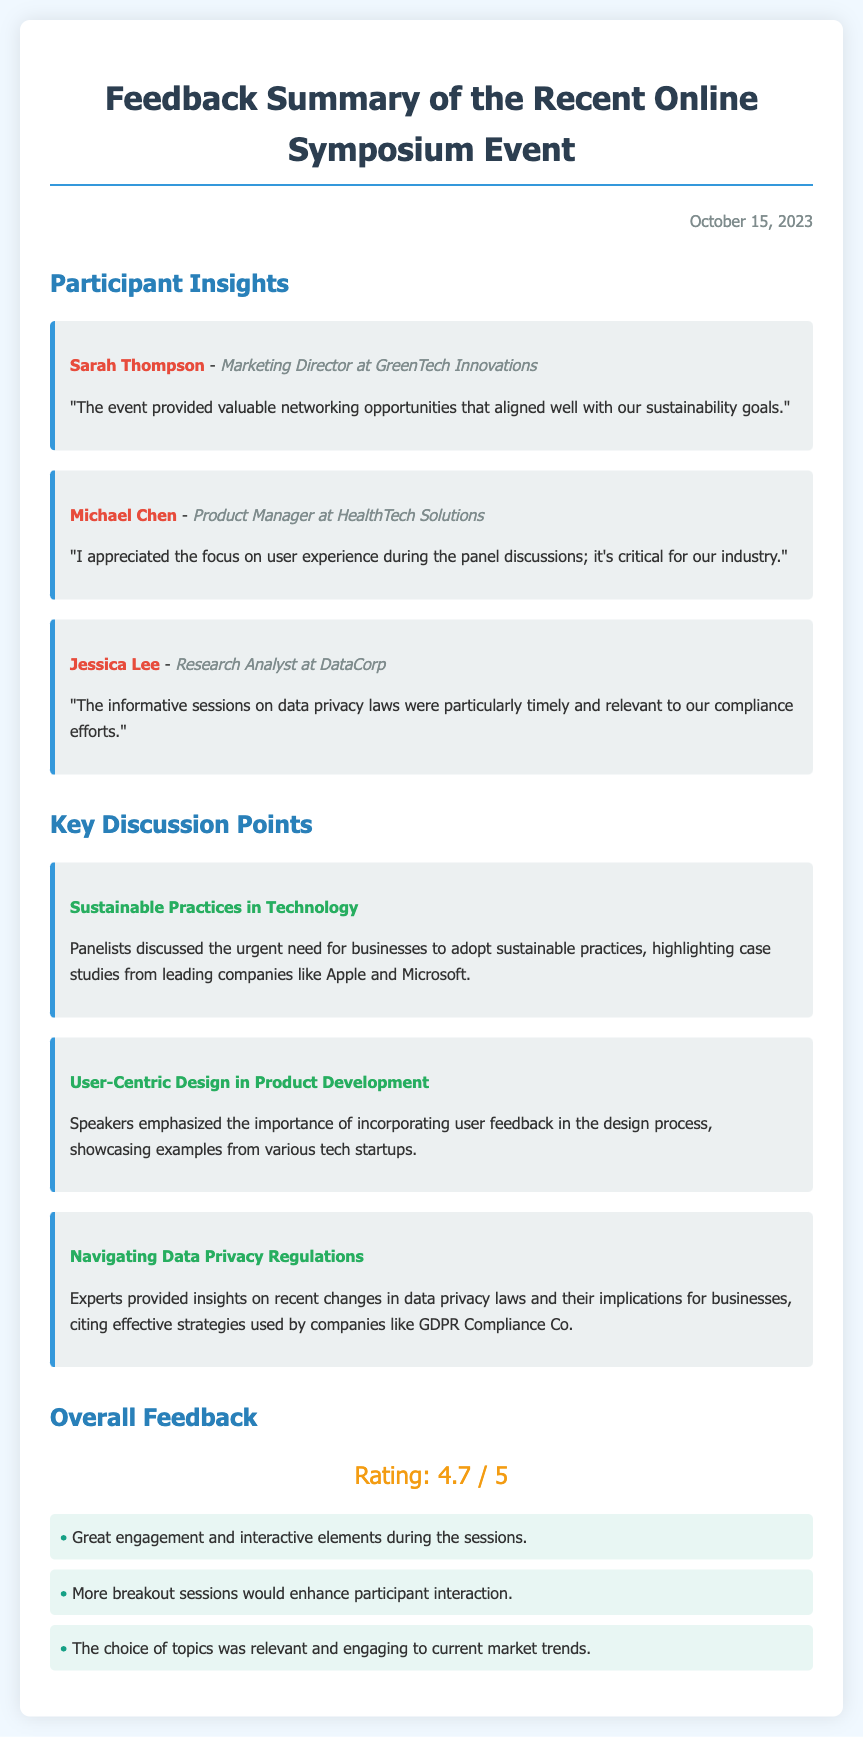What is the date of the feedback summary? The date is mentioned in the document header as October 15, 2023.
Answer: October 15, 2023 Who is the Marketing Director at GreenTech Innovations? The participant insight section contains the name Sarah Thompson as the Marketing Director at GreenTech Innovations.
Answer: Sarah Thompson What was the overall rating of the event? The overall feedback includes a rating section with a score of 4.7 out of 5.
Answer: 4.7 / 5 What topic was discussed regarding user feedback? The document highlights "User-Centric Design in Product Development" emphasizing the importance of incorporating user feedback.
Answer: User-Centric Design in Product Development Which company was cited as an example in sustainable practices? The discussion point mentions leading companies like Apple and Microsoft in the context of sustainable practices.
Answer: Apple and Microsoft What type of professional is Jessica Lee? The document lists Jessica Lee as a Research Analyst at DataCorp in the participant insights.
Answer: Research Analyst What was a suggested improvement mentioned in the feedback? One of the comments suggests that more breakout sessions would enhance participant interaction.
Answer: More breakout sessions Which topic was highlighted as timely and relevant by Jessica Lee? Jessica Lee mentioned informative sessions on data privacy laws as particularly timely and relevant to compliance efforts.
Answer: Data privacy laws What industry does Michael Chen represent? Michael Chen is identified as a Product Manager at HealthTech Solutions, indicating he represents the health technology industry.
Answer: Health technology 